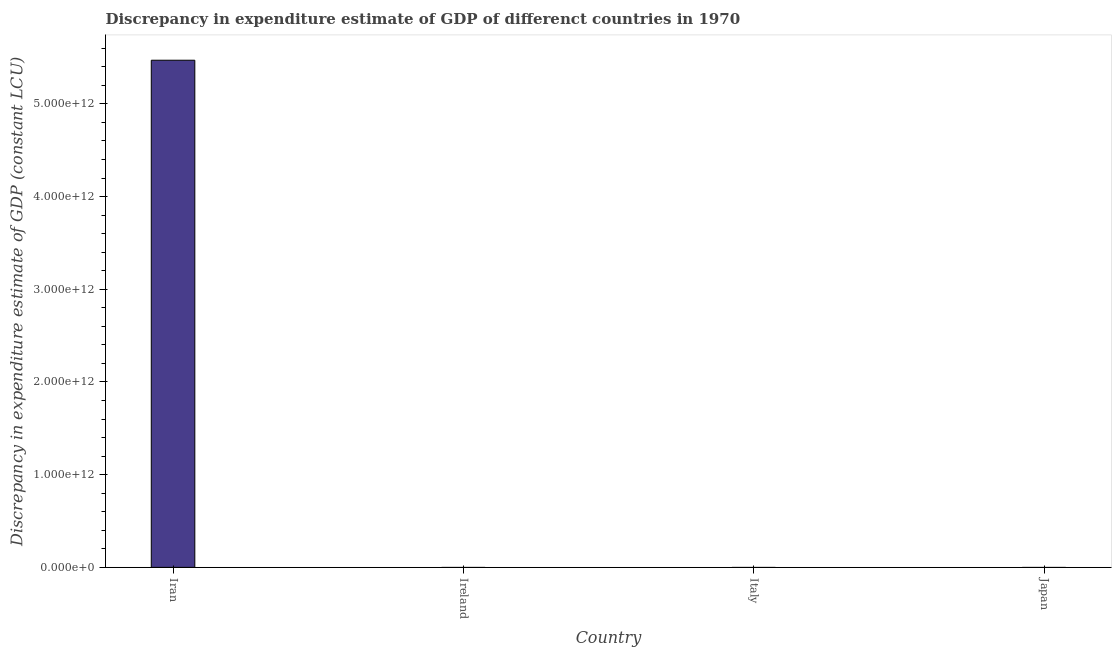Does the graph contain any zero values?
Give a very brief answer. Yes. What is the title of the graph?
Ensure brevity in your answer.  Discrepancy in expenditure estimate of GDP of differenct countries in 1970. What is the label or title of the X-axis?
Provide a succinct answer. Country. What is the label or title of the Y-axis?
Offer a terse response. Discrepancy in expenditure estimate of GDP (constant LCU). What is the discrepancy in expenditure estimate of gdp in Italy?
Give a very brief answer. 0. Across all countries, what is the maximum discrepancy in expenditure estimate of gdp?
Offer a terse response. 5.47e+12. In which country was the discrepancy in expenditure estimate of gdp maximum?
Ensure brevity in your answer.  Iran. What is the sum of the discrepancy in expenditure estimate of gdp?
Make the answer very short. 5.47e+12. What is the average discrepancy in expenditure estimate of gdp per country?
Give a very brief answer. 1.37e+12. What is the difference between the highest and the lowest discrepancy in expenditure estimate of gdp?
Offer a terse response. 5.47e+12. In how many countries, is the discrepancy in expenditure estimate of gdp greater than the average discrepancy in expenditure estimate of gdp taken over all countries?
Your answer should be compact. 1. What is the difference between two consecutive major ticks on the Y-axis?
Keep it short and to the point. 1.00e+12. What is the Discrepancy in expenditure estimate of GDP (constant LCU) of Iran?
Your answer should be very brief. 5.47e+12. What is the Discrepancy in expenditure estimate of GDP (constant LCU) in Italy?
Make the answer very short. 0. What is the Discrepancy in expenditure estimate of GDP (constant LCU) of Japan?
Your answer should be compact. 0. 